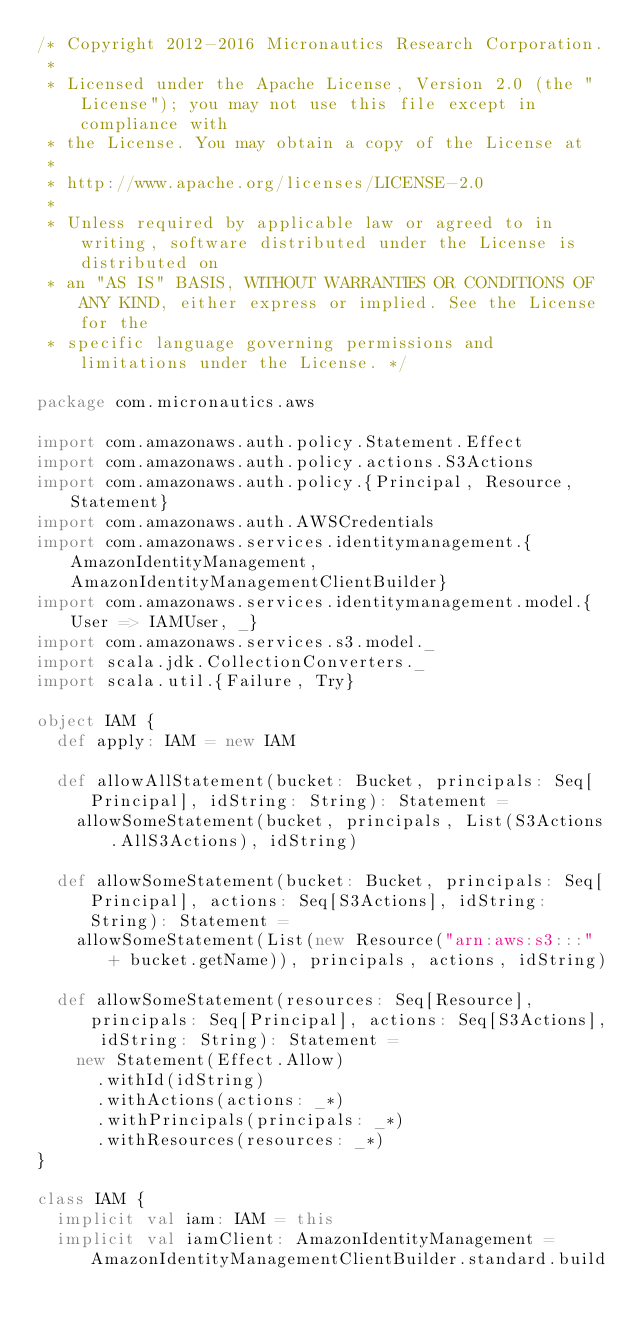<code> <loc_0><loc_0><loc_500><loc_500><_Scala_>/* Copyright 2012-2016 Micronautics Research Corporation.
 *
 * Licensed under the Apache License, Version 2.0 (the "License"); you may not use this file except in compliance with
 * the License. You may obtain a copy of the License at
 *
 * http://www.apache.org/licenses/LICENSE-2.0
 *
 * Unless required by applicable law or agreed to in writing, software distributed under the License is distributed on
 * an "AS IS" BASIS, WITHOUT WARRANTIES OR CONDITIONS OF ANY KIND, either express or implied. See the License for the
 * specific language governing permissions and limitations under the License. */

package com.micronautics.aws

import com.amazonaws.auth.policy.Statement.Effect
import com.amazonaws.auth.policy.actions.S3Actions
import com.amazonaws.auth.policy.{Principal, Resource, Statement}
import com.amazonaws.auth.AWSCredentials
import com.amazonaws.services.identitymanagement.{AmazonIdentityManagement, AmazonIdentityManagementClientBuilder}
import com.amazonaws.services.identitymanagement.model.{User => IAMUser, _}
import com.amazonaws.services.s3.model._
import scala.jdk.CollectionConverters._
import scala.util.{Failure, Try}

object IAM {
  def apply: IAM = new IAM

  def allowAllStatement(bucket: Bucket, principals: Seq[Principal], idString: String): Statement =
    allowSomeStatement(bucket, principals, List(S3Actions.AllS3Actions), idString)

  def allowSomeStatement(bucket: Bucket, principals: Seq[Principal], actions: Seq[S3Actions], idString: String): Statement =
    allowSomeStatement(List(new Resource("arn:aws:s3:::" + bucket.getName)), principals, actions, idString)

  def allowSomeStatement(resources: Seq[Resource], principals: Seq[Principal], actions: Seq[S3Actions], idString: String): Statement =
    new Statement(Effect.Allow)
      .withId(idString)
      .withActions(actions: _*)
      .withPrincipals(principals: _*)
      .withResources(resources: _*)
}

class IAM {
  implicit val iam: IAM = this
  implicit val iamClient: AmazonIdentityManagement = AmazonIdentityManagementClientBuilder.standard.build
</code> 